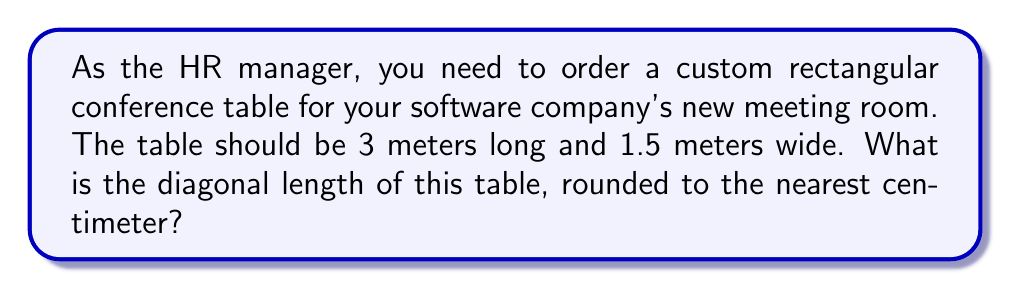Could you help me with this problem? To find the diagonal length of a rectangular table, we can use the Pythagorean theorem. Let's approach this step-by-step:

1. Identify the known dimensions:
   Length (l) = 3 meters
   Width (w) = 1.5 meters

2. Apply the Pythagorean theorem:
   $$ d^2 = l^2 + w^2 $$
   Where d is the diagonal length

3. Substitute the known values:
   $$ d^2 = 3^2 + 1.5^2 $$

4. Calculate the squares:
   $$ d^2 = 9 + 2.25 $$

5. Sum the squares:
   $$ d^2 = 11.25 $$

6. Take the square root of both sides:
   $$ d = \sqrt{11.25} $$

7. Calculate the square root:
   $$ d \approx 3.3541 \text{ meters} $$

8. Round to the nearest centimeter:
   $$ d \approx 3.35 \text{ meters} $$

[asy]
unitsize(30);
draw((0,0)--(3,0)--(3,1.5)--(0,1.5)--cycle);
draw((0,0)--(3,1.5),dashed);
label("3 m", (1.5,0), S);
label("1.5 m", (3,0.75), E);
label("d", (1.5,0.75), NW);
[/asy]
Answer: 3.35 m 